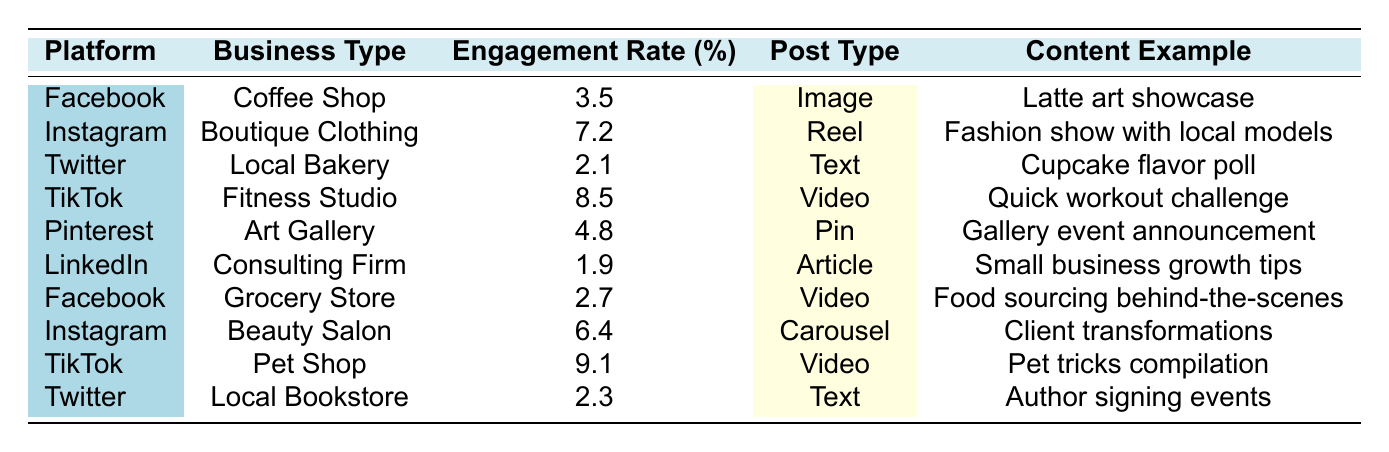What is the highest engagement rate among local businesses on social media? From the table, the engagement rates for each business type are as follows: Coffee Shop (3.5%), Boutique Clothing Store (7.2%), Local Bakery (2.1%), Fitness Studio (8.5%), Art Gallery (4.8%), Consulting Firm (1.9%), Grocery Store (2.7%), Beauty Salon (6.4%), Pet Shop (9.1%), and Local Bookstore (2.3%). The highest engagement rate is 9.1% from the Pet Shop on TikTok.
Answer: 9.1% Which platform has the lowest engagement rate? By reviewing the engagement rates listed, the Consulting Firm on LinkedIn has the lowest engagement rate at 1.9%.
Answer: LinkedIn (1.9%) What type of content did the Fitness Studio use to achieve their engagement rate? According to the table, the Fitness Studio used a Video post type, and the content example provided is "Quick workout tips in a fun challenge format."
Answer: Video (Quick workout tips) Which business type had the highest engagement rate on Instagram? In the table, the Boutique Clothing Store had an engagement rate of 7.2% on Instagram.
Answer: Boutique Clothing Store (7.2%) What is the average engagement rate for the listed platforms? The engagement rates are: 3.5, 7.2, 2.1, 8.5, 4.8, 1.9, 2.7, 6.4, 9.1, 2.3. Adding these gives a total of 48.1, and there are 10 entries, so the average is 48.1/10 = 4.81.
Answer: 4.81 Is there any business type that used a Text post type with an engagement rate above 2%? The Local Bakery has a Text post type and an engagement rate of 2.1%, and the Local Bookstore also has a Text post type with an engagement rate of 2.3%. Both are above 2%.
Answer: Yes Which post type yielded the highest engagement rate among all entries? Evaluating the engagement rates for each post type: Image (3.5%), Reel (7.2%), Text (2.1% and 2.3%), Video (8.5% and 9.1%), Pin (4.8%), and Article (1.9%). The Video post type had the highest engagement rate at 9.1% from the Pet Shop.
Answer: Video (9.1%) How does the engagement rate of the Grocery Store compare to that of the Coffee Shop? The Grocery Store has an engagement rate of 2.7% while the Coffee Shop has a rate of 3.5%. Therefore, the Grocery Store's engagement rate is lower than that of the Coffee Shop.
Answer: Lower What content examples lead to higher engagement rates, videos or images? Videos from the Fitness Studio (8.5%) and Pet Shop (9.1%) yield much higher engagement compared to the Coffee Shop's Image post (3.5%). Thus, videos generally result in higher engagement rates than images here.
Answer: Videos (Higher engagement rates) Does Pinterest have a higher engagement rate than Twitter? Pinterest has an engagement rate of 4.8% while Twitter has rates of 2.1% and 2.3%. Therefore, Pinterest does have a higher engagement rate than both Twitter entries.
Answer: Yes 